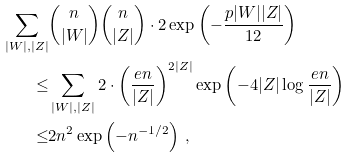<formula> <loc_0><loc_0><loc_500><loc_500>\sum _ { | W | , | Z | } & \binom { n } { | W | } \binom { n } { | Z | } \cdot 2 \exp \left ( - \frac { p | W | | Z | } { 1 2 } \right ) \\ \leq & \sum _ { | W | , | Z | } 2 \cdot \left ( \frac { e n } { | Z | } \right ) ^ { 2 | Z | } \exp \left ( - 4 | Z | \log \frac { e n } { | Z | } \right ) \\ \leq & 2 n ^ { 2 } \exp \left ( - n ^ { - 1 / 2 } \right ) \, ,</formula> 